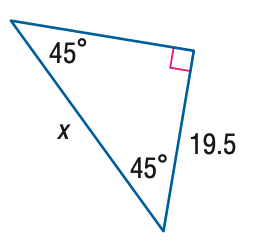Answer the mathemtical geometry problem and directly provide the correct option letter.
Question: Find x.
Choices: A: \frac { 39 \sqrt { 2 } } { 4 } B: \frac { 39 \sqrt { 2 } } { 2 } C: \frac { 39 \sqrt { 3 } } { 2 } D: 39 B 